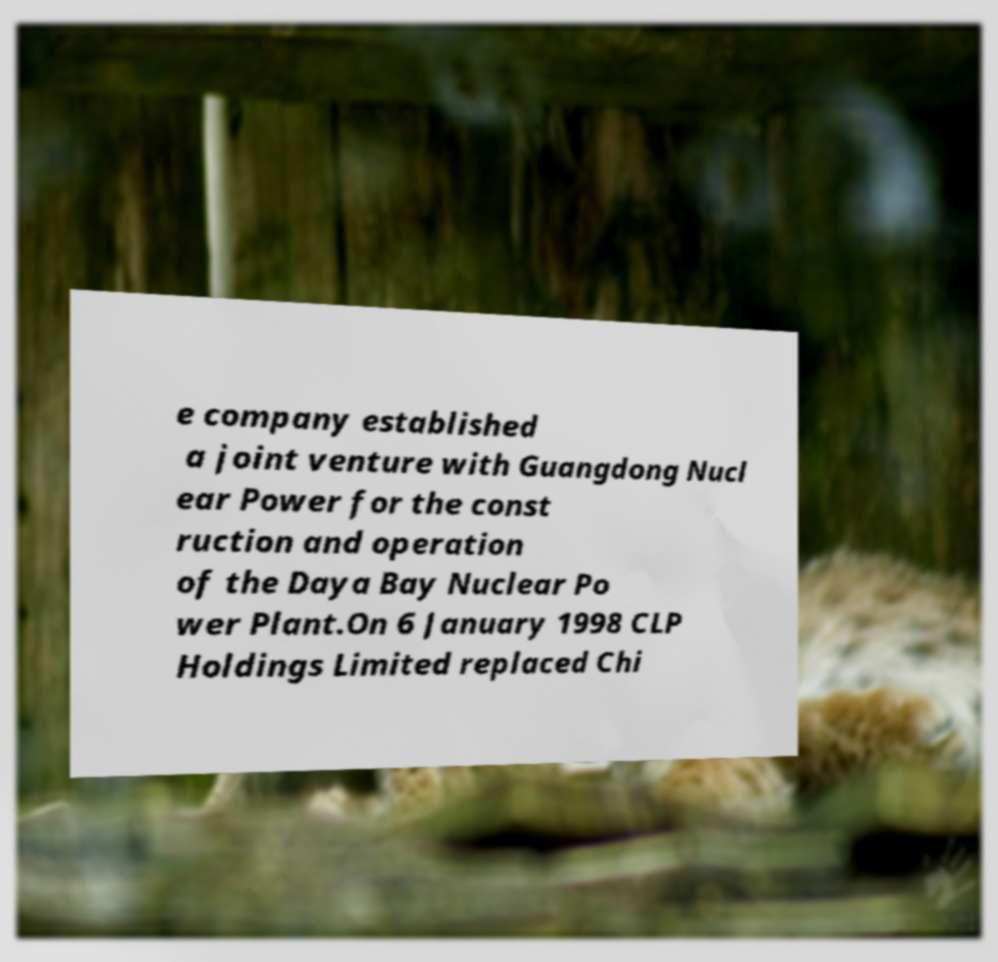Please identify and transcribe the text found in this image. e company established a joint venture with Guangdong Nucl ear Power for the const ruction and operation of the Daya Bay Nuclear Po wer Plant.On 6 January 1998 CLP Holdings Limited replaced Chi 